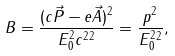<formula> <loc_0><loc_0><loc_500><loc_500>B = \frac { ( c \vec { P } - e \vec { A } ) ^ { 2 } } { E _ { 0 } ^ { 2 } c ^ { 2 } { } ^ { 2 } } = \frac { { p } ^ { 2 } } { E _ { 0 } ^ { 2 } { } ^ { 2 } } ,</formula> 